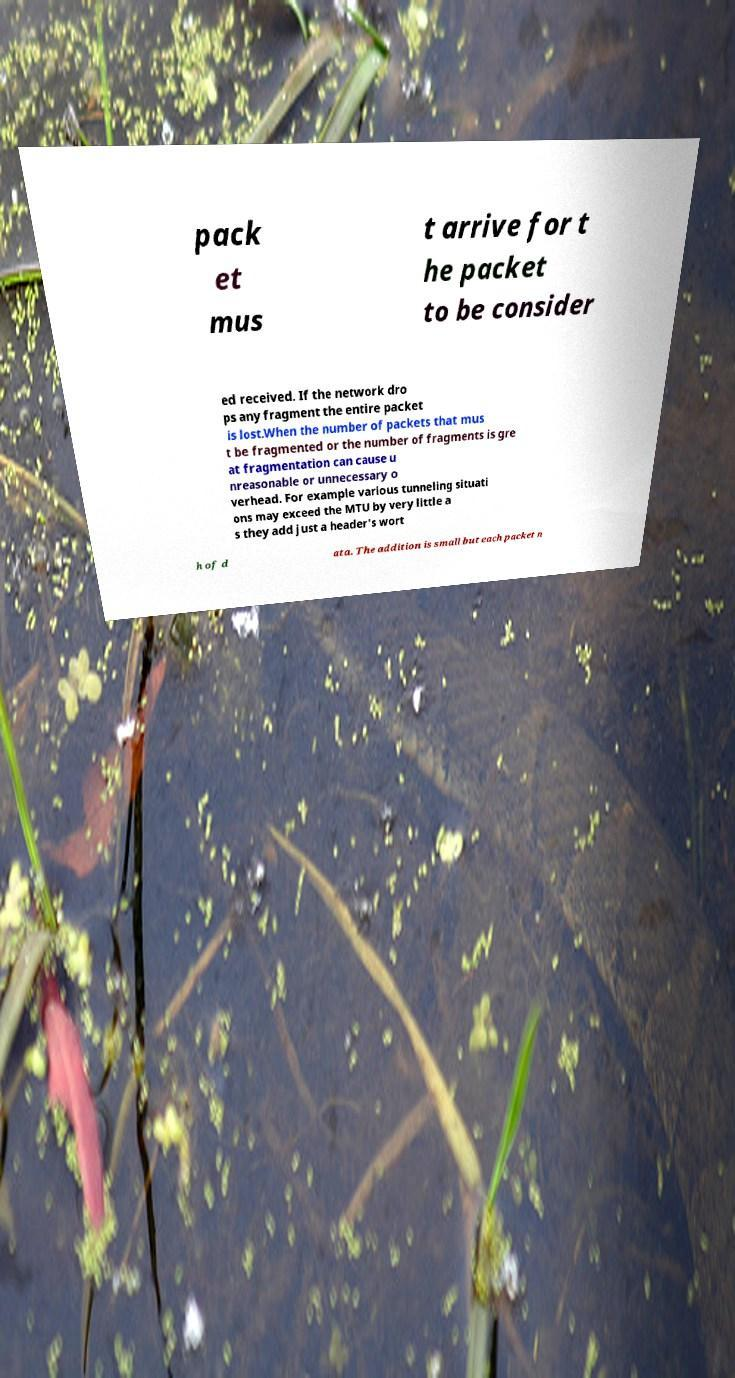Please identify and transcribe the text found in this image. pack et mus t arrive for t he packet to be consider ed received. If the network dro ps any fragment the entire packet is lost.When the number of packets that mus t be fragmented or the number of fragments is gre at fragmentation can cause u nreasonable or unnecessary o verhead. For example various tunneling situati ons may exceed the MTU by very little a s they add just a header's wort h of d ata. The addition is small but each packet n 